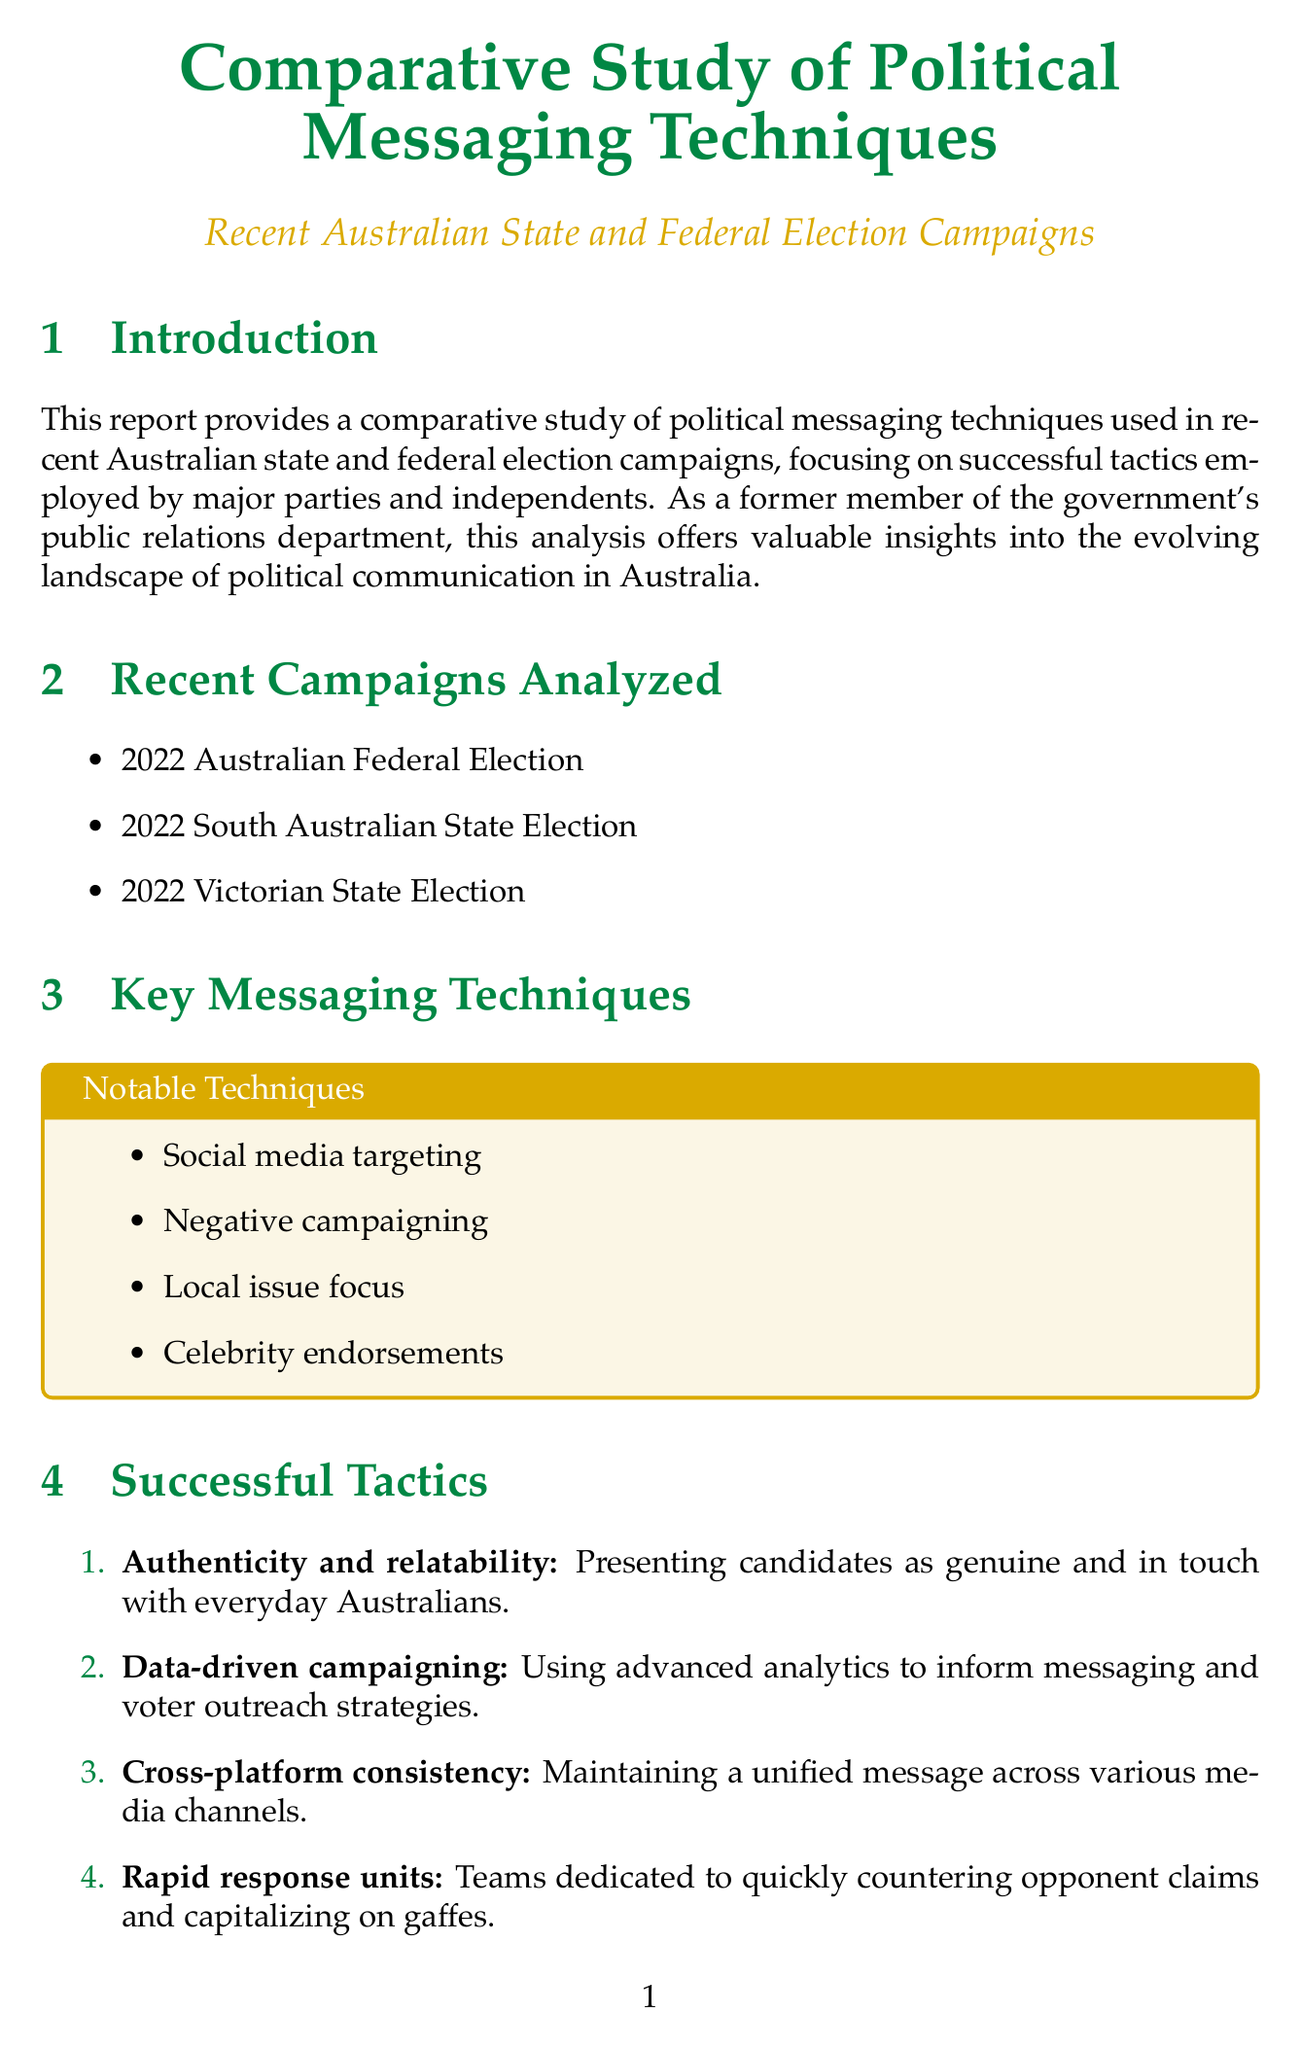what was the focus of the comparative study? The focus of the study is on political messaging techniques used in recent Australian state and federal election campaigns.
Answer: political messaging techniques which party used TikTok to engage younger voters? This example illustrates the specific campaign strategy used by the Labor Party in the 2022 federal election.
Answer: Labor Party what tactic emphasizes addressing specific concerns of electorates? This tactic is aimed at tailoring messages to the needs of local voters.
Answer: Local issue focus how did Daniel Andrews' campaign benefit from a specific narrative? The document mentions the effective use of a narrative related to COVID-19 response contributing to his campaign's success.
Answer: COVID-19 response narrative what was a key tactic used by the Teal Independents? Identifying the strategy they implemented to connect with local communities in their campaign can be found in the case study.
Answer: Grassroots community engagement how many major elections were analyzed in the document? This number refers to the state and federal elections included in the study.
Answer: Three what is a challenge mentioned in the analysis section? This challenge affects campaigns in their ability to connect with voters and is highlighted in the analysis.
Answer: Combating misinformation which party deployed a 'Fact Check Unit' during their campaign? Referring to the rapid response strategy used to counter misinformation during the election.
Answer: ALP what successful tactic involves maintaining a unified message? This tactic outlines a strategic approach across different media used in political campaigns.
Answer: Cross-platform consistency 